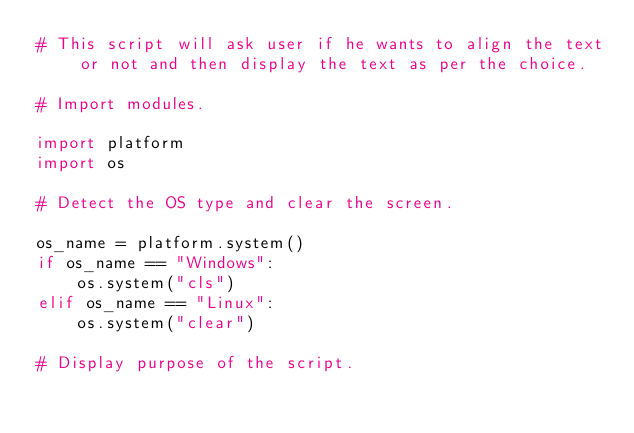Convert code to text. <code><loc_0><loc_0><loc_500><loc_500><_Python_># This script will ask user if he wants to align the text or not and then display the text as per the choice.

# Import modules.

import platform
import os

# Detect the OS type and clear the screen.

os_name = platform.system()
if os_name == "Windows":
    os.system("cls")
elif os_name == "Linux":
    os.system("clear")

# Display purpose of the script.
</code> 